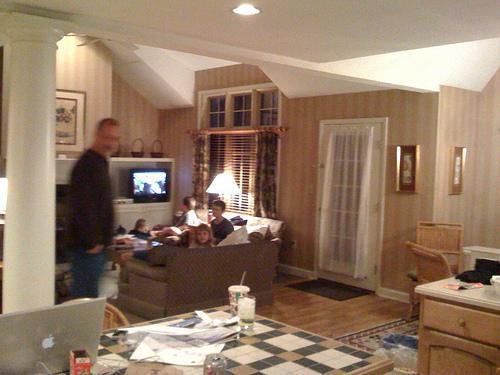How many people are in this picture?
Give a very brief answer. 5. How many drawers are visible?
Give a very brief answer. 1. How many people can be seen?
Give a very brief answer. 5. 